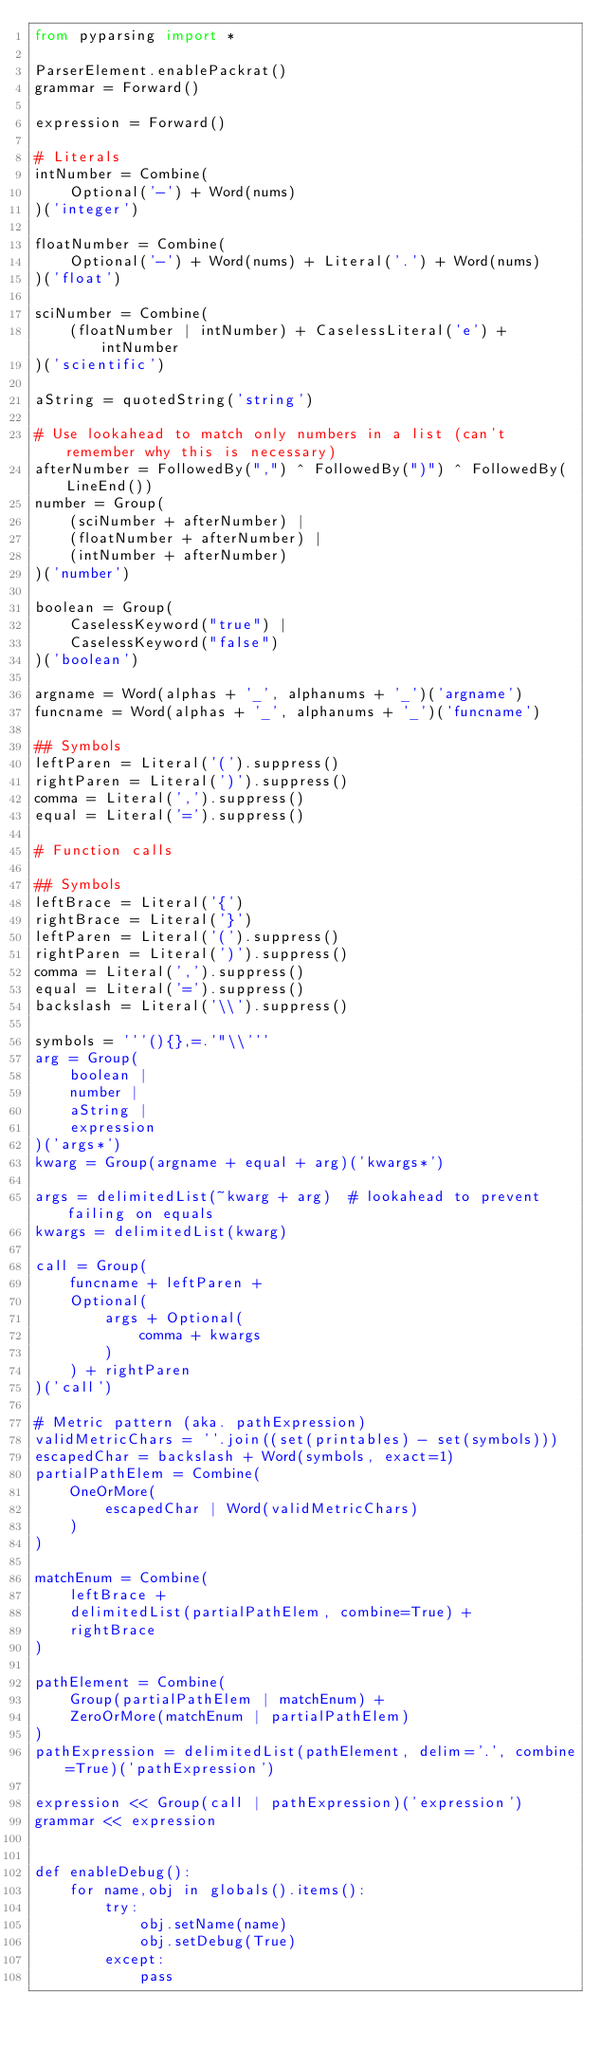<code> <loc_0><loc_0><loc_500><loc_500><_Python_>from pyparsing import *

ParserElement.enablePackrat()
grammar = Forward()

expression = Forward()

# Literals
intNumber = Combine(
    Optional('-') + Word(nums)
)('integer')

floatNumber = Combine(
    Optional('-') + Word(nums) + Literal('.') + Word(nums)
)('float')

sciNumber = Combine(
    (floatNumber | intNumber) + CaselessLiteral('e') + intNumber
)('scientific')

aString = quotedString('string')

# Use lookahead to match only numbers in a list (can't remember why this is necessary)
afterNumber = FollowedBy(",") ^ FollowedBy(")") ^ FollowedBy(LineEnd())
number = Group(
    (sciNumber + afterNumber) |
    (floatNumber + afterNumber) |
    (intNumber + afterNumber)
)('number')

boolean = Group(
    CaselessKeyword("true") |
    CaselessKeyword("false")
)('boolean')

argname = Word(alphas + '_', alphanums + '_')('argname')
funcname = Word(alphas + '_', alphanums + '_')('funcname')

## Symbols
leftParen = Literal('(').suppress()
rightParen = Literal(')').suppress()
comma = Literal(',').suppress()
equal = Literal('=').suppress()

# Function calls

## Symbols
leftBrace = Literal('{')
rightBrace = Literal('}')
leftParen = Literal('(').suppress()
rightParen = Literal(')').suppress()
comma = Literal(',').suppress()
equal = Literal('=').suppress()
backslash = Literal('\\').suppress()

symbols = '''(){},=.'"\\'''
arg = Group(
    boolean |
    number |
    aString |
    expression
)('args*')
kwarg = Group(argname + equal + arg)('kwargs*')

args = delimitedList(~kwarg + arg)  # lookahead to prevent failing on equals
kwargs = delimitedList(kwarg)

call = Group(
    funcname + leftParen +
    Optional(
        args + Optional(
            comma + kwargs
        )
    ) + rightParen
)('call')

# Metric pattern (aka. pathExpression)
validMetricChars = ''.join((set(printables) - set(symbols)))
escapedChar = backslash + Word(symbols, exact=1)
partialPathElem = Combine(
    OneOrMore(
        escapedChar | Word(validMetricChars)
    )
)

matchEnum = Combine(
    leftBrace +
    delimitedList(partialPathElem, combine=True) +
    rightBrace
)

pathElement = Combine(
    Group(partialPathElem | matchEnum) +
    ZeroOrMore(matchEnum | partialPathElem)
)
pathExpression = delimitedList(pathElement, delim='.', combine=True)('pathExpression')

expression << Group(call | pathExpression)('expression')
grammar << expression


def enableDebug():
    for name,obj in globals().items():
        try:
            obj.setName(name)
            obj.setDebug(True)
        except:
            pass
</code> 